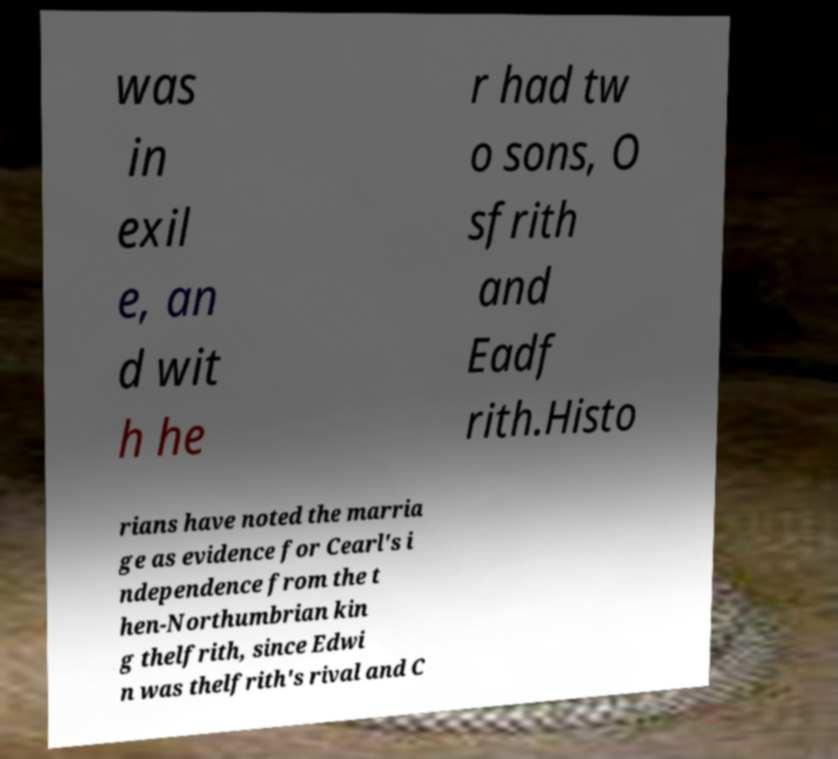For documentation purposes, I need the text within this image transcribed. Could you provide that? was in exil e, an d wit h he r had tw o sons, O sfrith and Eadf rith.Histo rians have noted the marria ge as evidence for Cearl's i ndependence from the t hen-Northumbrian kin g thelfrith, since Edwi n was thelfrith's rival and C 